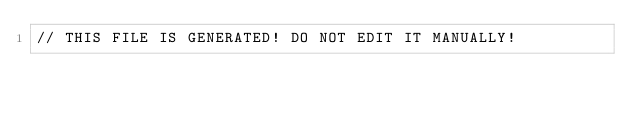<code> <loc_0><loc_0><loc_500><loc_500><_Kotlin_>// THIS FILE IS GENERATED! DO NOT EDIT IT MANUALLY!</code> 